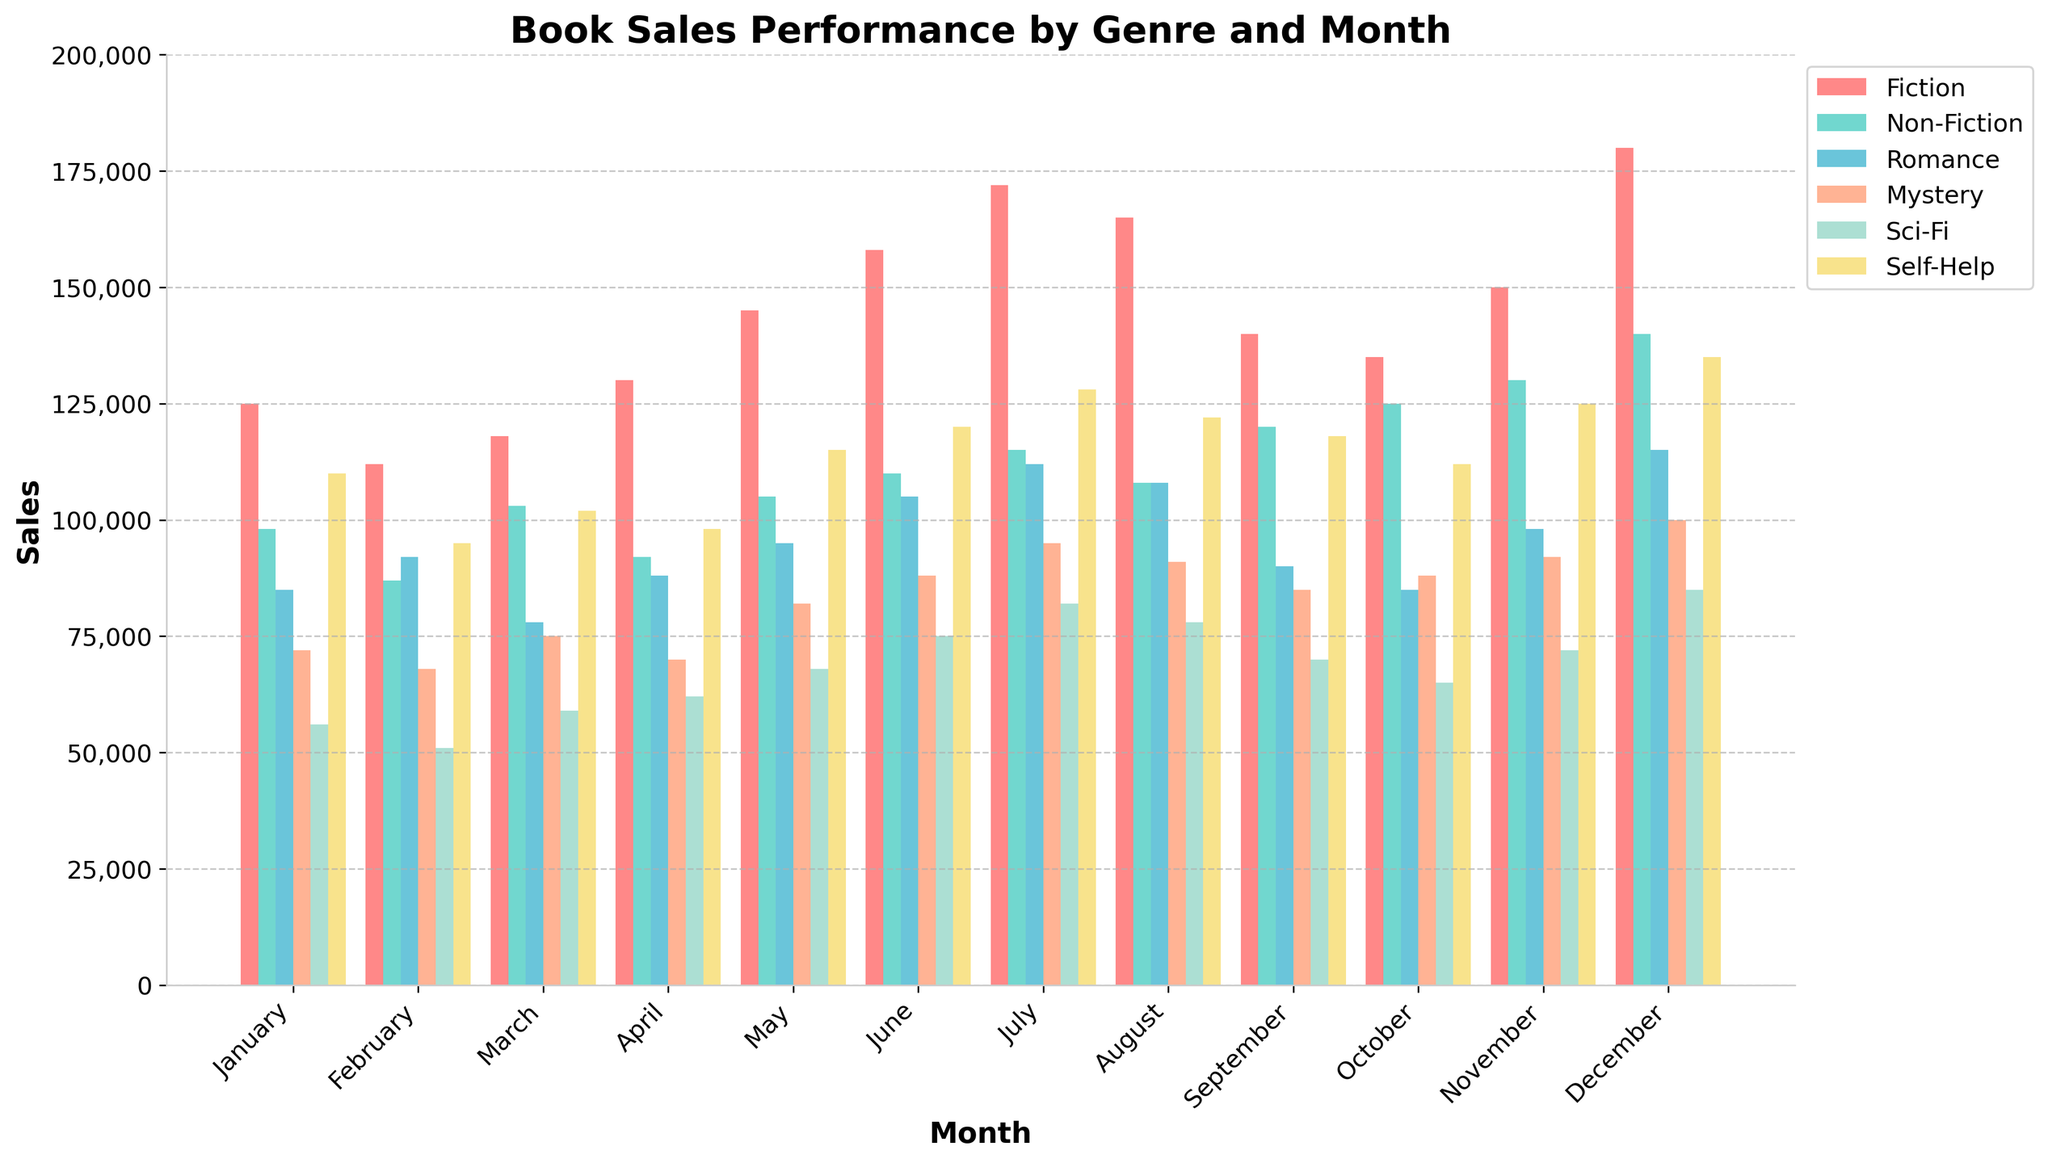What month had the highest Fiction book sales? To find the highest Fiction book sales, we need to look for the tallest bar corresponding to Fiction. In the provided figure, December has the tallest bar for Fiction.
Answer: December Which genre sold the most books in July? To determine which genre sold the most books in July, we compare the heights of all the bars for July. Fiction has the tallest bar in July.
Answer: Fiction In which month did Non-Fiction sales surpass 120,000 units? Look for months where the Non-Fiction bar is above the 120,000 mark on the y-axis. The months are October and November.
Answer: October, November Compare the Romance book sales in May to the Mystery book sales in May: which genre sold more? Compare the height of the Romance bar to the Mystery bar for May. The Romance bar is higher than the Mystery bar for May.
Answer: Romance What is the total book sales for Sci-Fi in the first quarter (January to March)? Add up the Sci-Fi sales from January to March: 56,000 (Jan) + 51,000 (Feb) + 59,000 (Mar) = 166,000.
Answer: 166,000 Did Self-Help book sales increase or decrease from July to August? Compare the height of the Self-Help bar for July to the Self-Help bar for August. The Self-Help sales bar for August is slightly lower than July, indicating a decrease.
Answer: Decrease Which month saw the lowest sales for Mystery books? Look for the shortest bar corresponding to Mystery across all months. The shortest bar for Mystery is in February.
Answer: February By how much did December’s Fiction book sales exceed November’s Fiction book sales? Subtract November's Fiction sales from December's Fiction sales: 180,000 (Dec) - 150,000 (Nov) = 30,000.
Answer: 30,000 What is the average monthly sales for Non-Fiction books throughout the year? Add up all the monthly Non-Fiction sales and divide by 12. (98,000 + 87,000 + 103,000 + 92,000 + 105,000 + 110,000 + 115,000 + 108,000 + 120,000 + 125,000 + 130,000 + 140,000) / 12 = 1153,000 / 12 ≈ 96,083.33
Answer: 96,083.33 